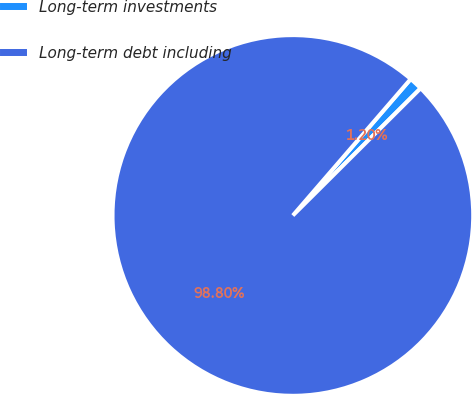<chart> <loc_0><loc_0><loc_500><loc_500><pie_chart><fcel>Long-term investments<fcel>Long-term debt including<nl><fcel>1.2%<fcel>98.8%<nl></chart> 